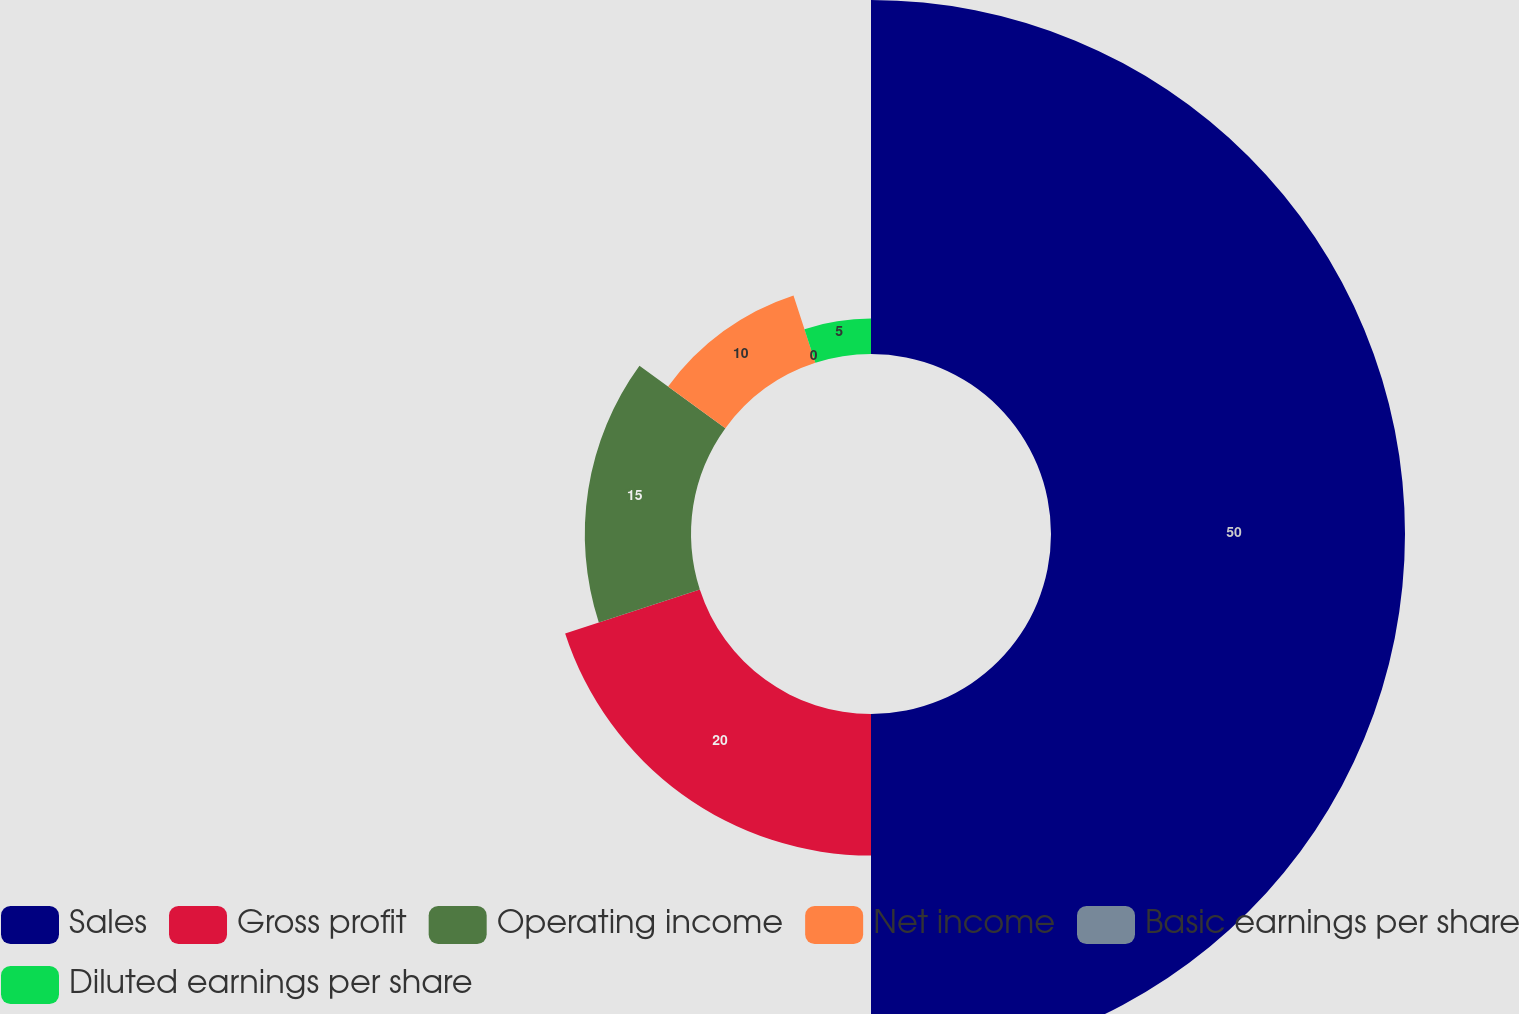Convert chart. <chart><loc_0><loc_0><loc_500><loc_500><pie_chart><fcel>Sales<fcel>Gross profit<fcel>Operating income<fcel>Net income<fcel>Basic earnings per share<fcel>Diluted earnings per share<nl><fcel>50.0%<fcel>20.0%<fcel>15.0%<fcel>10.0%<fcel>0.0%<fcel>5.0%<nl></chart> 